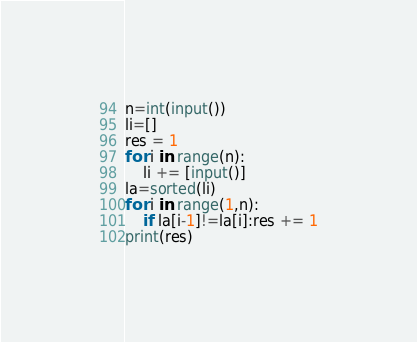Convert code to text. <code><loc_0><loc_0><loc_500><loc_500><_Python_>n=int(input())
li=[]
res = 1
for i in range(n):
    li += [input()]
la=sorted(li)
for i in range(1,n):
    if la[i-1]!=la[i]:res += 1
print(res)</code> 